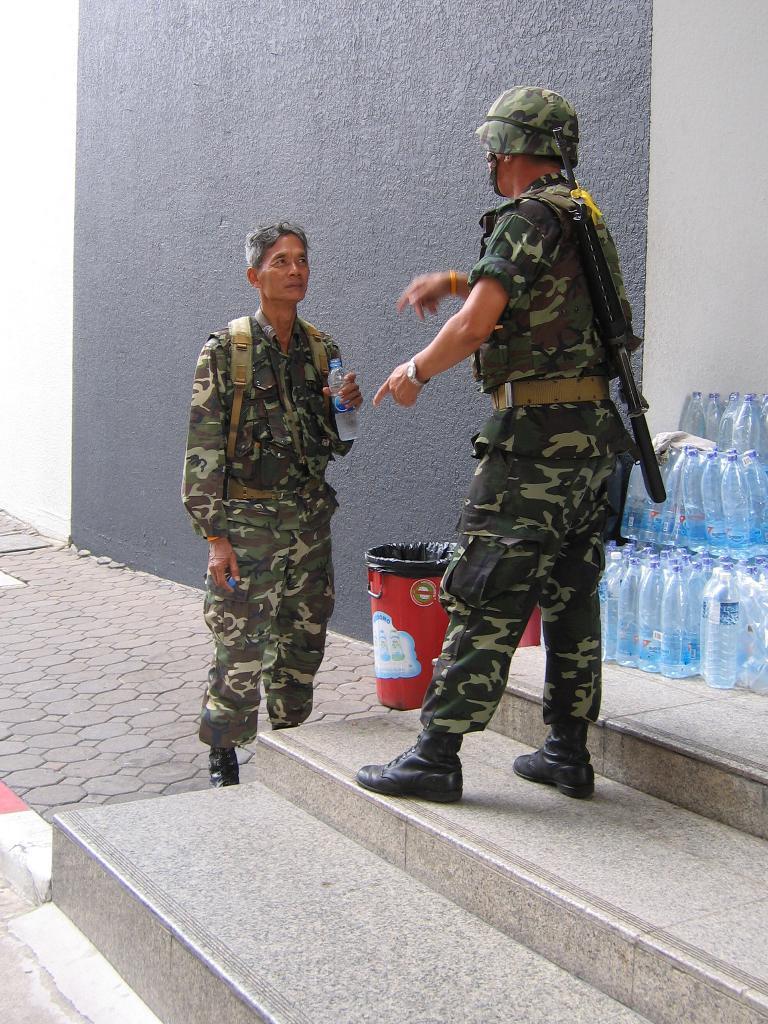In one or two sentences, can you explain what this image depicts? In this image we can see two men. They are wearing army uniform. One man is standing on the stairs. Behind him, bottles and dustbins are there. Background of the image grey color wall is present. 